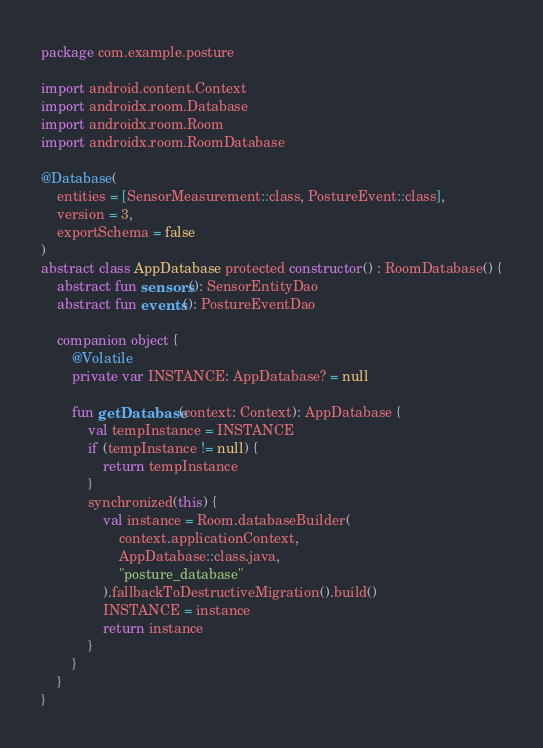<code> <loc_0><loc_0><loc_500><loc_500><_Kotlin_>package com.example.posture

import android.content.Context
import androidx.room.Database
import androidx.room.Room
import androidx.room.RoomDatabase

@Database(
    entities = [SensorMeasurement::class, PostureEvent::class],
    version = 3,
    exportSchema = false
)
abstract class AppDatabase protected constructor() : RoomDatabase() {
    abstract fun sensors(): SensorEntityDao
    abstract fun events(): PostureEventDao

    companion object {
        @Volatile
        private var INSTANCE: AppDatabase? = null

        fun getDatabase(context: Context): AppDatabase {
            val tempInstance = INSTANCE
            if (tempInstance != null) {
                return tempInstance
            }
            synchronized(this) {
                val instance = Room.databaseBuilder(
                    context.applicationContext,
                    AppDatabase::class.java,
                    "posture_database"
                ).fallbackToDestructiveMigration().build()
                INSTANCE = instance
                return instance
            }
        }
    }
}</code> 